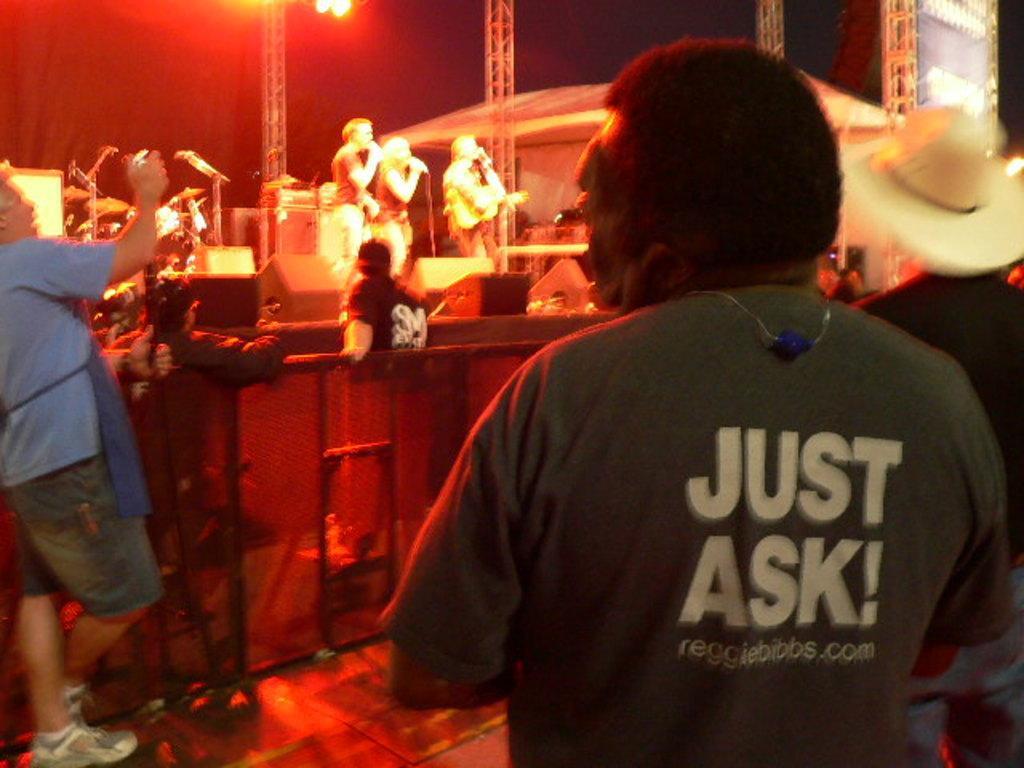Describe this image in one or two sentences. In the picture we can see a man standing in a T-shirt written on it as just ask and in front of him we can see another man standing near the stage and on the stage we can see some people are giving musical performance and behind them we can see some poles and light to the ceiling. 